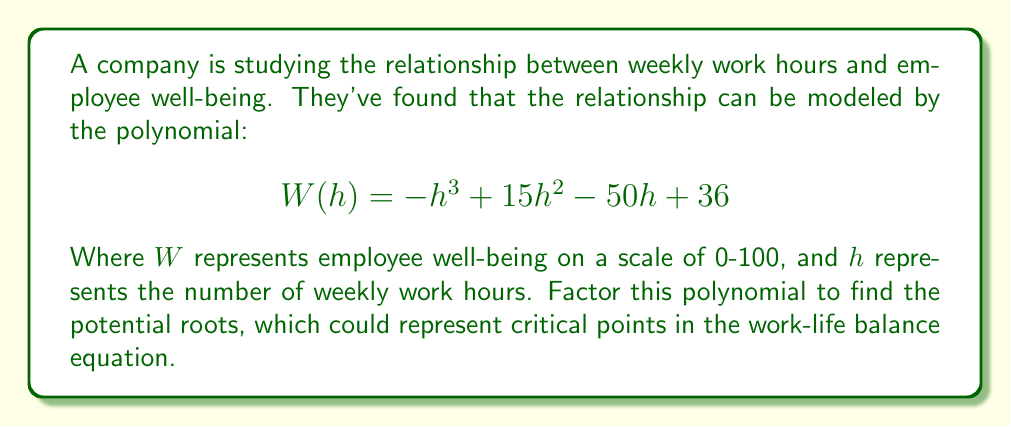What is the answer to this math problem? To factor this polynomial, we'll follow these steps:

1) First, let's check if there are any rational roots using the rational root theorem. The possible rational roots are the factors of the constant term (36): ±1, ±2, ±3, ±4, ±6, ±9, ±12, ±18, ±36.

2) Testing these values, we find that $h = 4$ is a root. So $(h - 4)$ is a factor.

3) We can use polynomial long division to divide $-h^3 + 15h^2 - 50h + 36$ by $(h - 4)$:

   $$-h^3 + 15h^2 - 50h + 36 = (h - 4)(-h^2 + 11h - 9)$$

4) Now we need to factor the quadratic $-h^2 + 11h - 9$. We can do this by finding two numbers that multiply to give -9 and add to give 11. These numbers are 9 and 2.

5) So, $-h^2 + 11h - 9 = -(h - 9)(h - 2)$

6) Putting it all together:

   $$W(h) = -h^3 + 15h^2 - 50h + 36 = -(h - 4)(h - 9)(h - 2)$$

This factorization shows that the polynomial has roots at $h = 4$, $h = 9$, and $h = 2$, which could represent critical points in the work-life balance equation.
Answer: $$W(h) = -(h - 4)(h - 9)(h - 2)$$ 